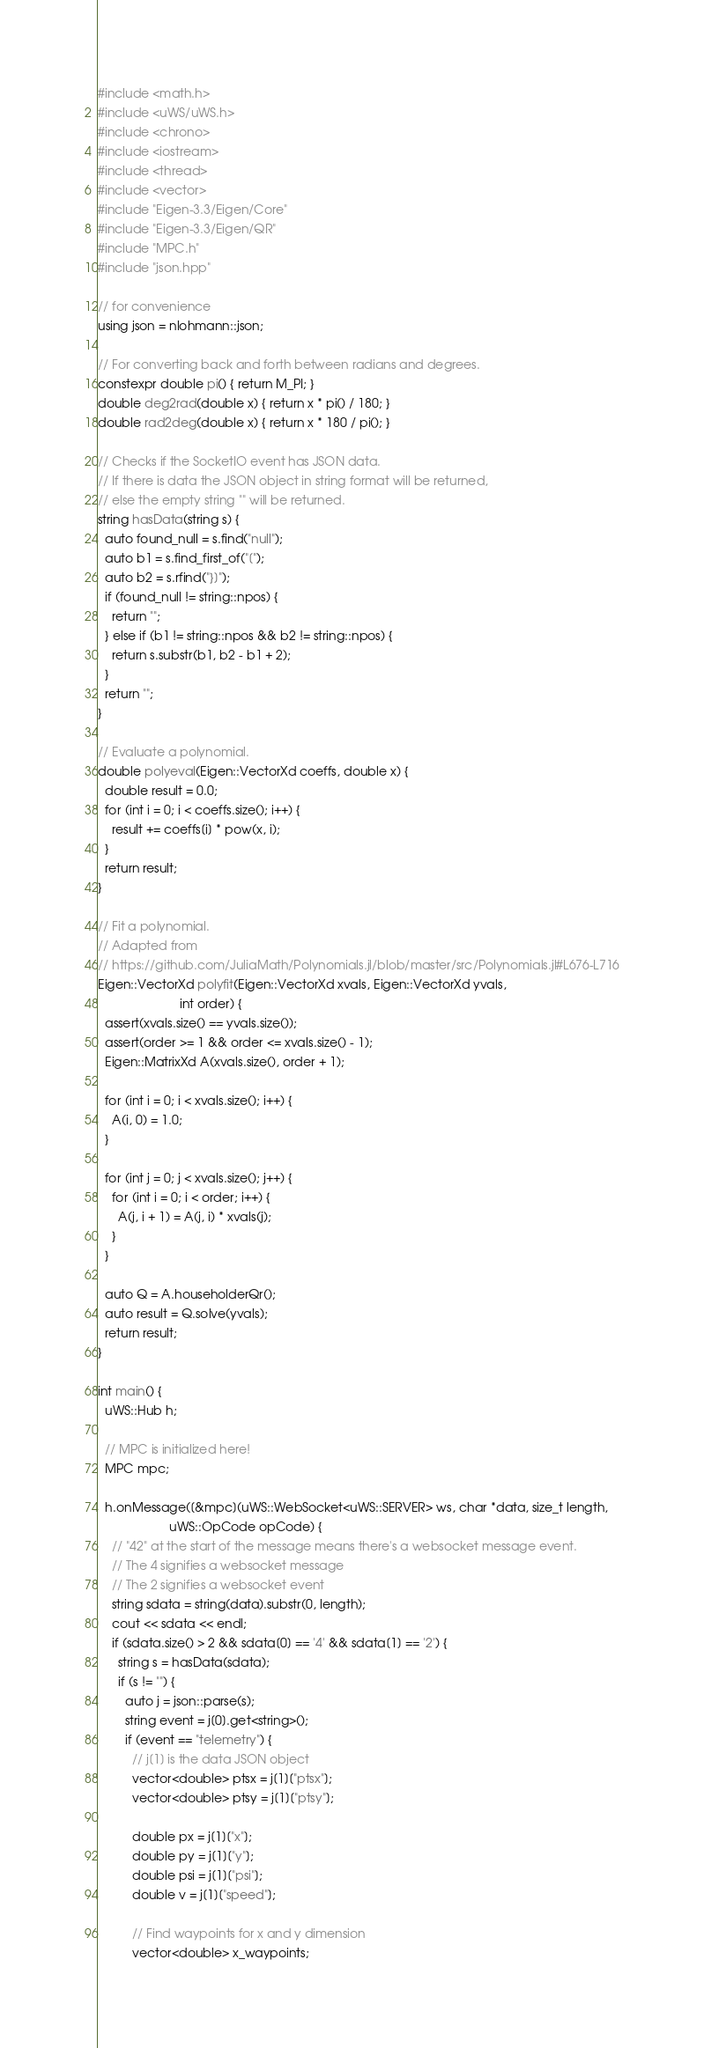Convert code to text. <code><loc_0><loc_0><loc_500><loc_500><_C++_>#include <math.h>
#include <uWS/uWS.h>
#include <chrono>
#include <iostream>
#include <thread>
#include <vector>
#include "Eigen-3.3/Eigen/Core"
#include "Eigen-3.3/Eigen/QR"
#include "MPC.h"
#include "json.hpp"

// for convenience
using json = nlohmann::json;

// For converting back and forth between radians and degrees.
constexpr double pi() { return M_PI; }
double deg2rad(double x) { return x * pi() / 180; }
double rad2deg(double x) { return x * 180 / pi(); }

// Checks if the SocketIO event has JSON data.
// If there is data the JSON object in string format will be returned,
// else the empty string "" will be returned.
string hasData(string s) {
  auto found_null = s.find("null");
  auto b1 = s.find_first_of("[");
  auto b2 = s.rfind("}]");
  if (found_null != string::npos) {
    return "";
  } else if (b1 != string::npos && b2 != string::npos) {
    return s.substr(b1, b2 - b1 + 2);
  }
  return "";
}

// Evaluate a polynomial.
double polyeval(Eigen::VectorXd coeffs, double x) {
  double result = 0.0;
  for (int i = 0; i < coeffs.size(); i++) {
    result += coeffs[i] * pow(x, i);
  }
  return result;
}

// Fit a polynomial.
// Adapted from
// https://github.com/JuliaMath/Polynomials.jl/blob/master/src/Polynomials.jl#L676-L716
Eigen::VectorXd polyfit(Eigen::VectorXd xvals, Eigen::VectorXd yvals,
                        int order) {
  assert(xvals.size() == yvals.size());
  assert(order >= 1 && order <= xvals.size() - 1);
  Eigen::MatrixXd A(xvals.size(), order + 1);

  for (int i = 0; i < xvals.size(); i++) {
    A(i, 0) = 1.0;
  }

  for (int j = 0; j < xvals.size(); j++) {
    for (int i = 0; i < order; i++) {
      A(j, i + 1) = A(j, i) * xvals(j);
    }
  }

  auto Q = A.householderQr();
  auto result = Q.solve(yvals);
  return result;
}

int main() {
  uWS::Hub h;

  // MPC is initialized here!
  MPC mpc;

  h.onMessage([&mpc](uWS::WebSocket<uWS::SERVER> ws, char *data, size_t length,
                     uWS::OpCode opCode) {
    // "42" at the start of the message means there's a websocket message event.
    // The 4 signifies a websocket message
    // The 2 signifies a websocket event
    string sdata = string(data).substr(0, length);
    cout << sdata << endl;
    if (sdata.size() > 2 && sdata[0] == '4' && sdata[1] == '2') {
      string s = hasData(sdata);
      if (s != "") {
        auto j = json::parse(s);
        string event = j[0].get<string>();
        if (event == "telemetry") {
          // j[1] is the data JSON object
          vector<double> ptsx = j[1]["ptsx"];
          vector<double> ptsy = j[1]["ptsy"];

          double px = j[1]["x"];
          double py = j[1]["y"];
          double psi = j[1]["psi"];
          double v = j[1]["speed"];

          // Find waypoints for x and y dimension
          vector<double> x_waypoints;</code> 